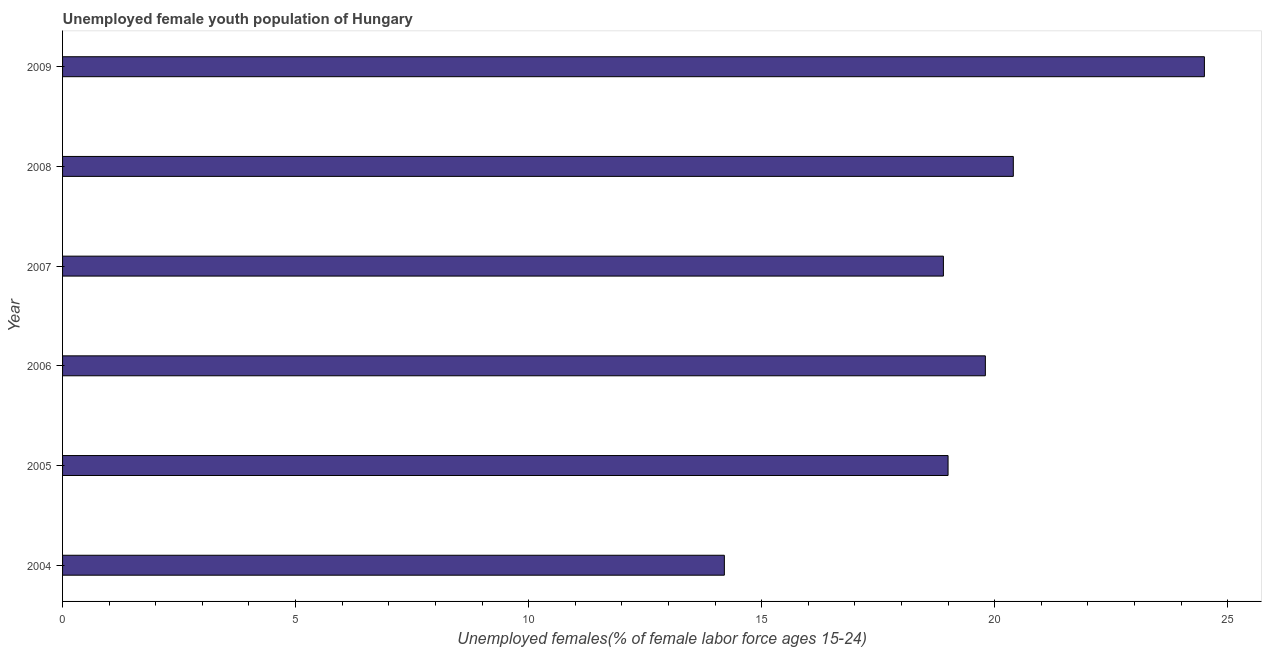Does the graph contain any zero values?
Provide a short and direct response. No. Does the graph contain grids?
Provide a short and direct response. No. What is the title of the graph?
Keep it short and to the point. Unemployed female youth population of Hungary. What is the label or title of the X-axis?
Keep it short and to the point. Unemployed females(% of female labor force ages 15-24). What is the label or title of the Y-axis?
Provide a succinct answer. Year. What is the unemployed female youth in 2004?
Provide a short and direct response. 14.2. Across all years, what is the minimum unemployed female youth?
Make the answer very short. 14.2. In which year was the unemployed female youth minimum?
Provide a short and direct response. 2004. What is the sum of the unemployed female youth?
Offer a very short reply. 116.8. What is the difference between the unemployed female youth in 2004 and 2007?
Your answer should be compact. -4.7. What is the average unemployed female youth per year?
Your answer should be compact. 19.47. What is the median unemployed female youth?
Your answer should be very brief. 19.4. In how many years, is the unemployed female youth greater than 20 %?
Provide a succinct answer. 2. What is the ratio of the unemployed female youth in 2006 to that in 2008?
Your response must be concise. 0.97. Is the unemployed female youth in 2005 less than that in 2006?
Offer a terse response. Yes. Is the sum of the unemployed female youth in 2004 and 2008 greater than the maximum unemployed female youth across all years?
Make the answer very short. Yes. In how many years, is the unemployed female youth greater than the average unemployed female youth taken over all years?
Offer a very short reply. 3. How many years are there in the graph?
Provide a succinct answer. 6. What is the difference between two consecutive major ticks on the X-axis?
Keep it short and to the point. 5. Are the values on the major ticks of X-axis written in scientific E-notation?
Make the answer very short. No. What is the Unemployed females(% of female labor force ages 15-24) in 2004?
Offer a very short reply. 14.2. What is the Unemployed females(% of female labor force ages 15-24) in 2006?
Keep it short and to the point. 19.8. What is the Unemployed females(% of female labor force ages 15-24) in 2007?
Ensure brevity in your answer.  18.9. What is the Unemployed females(% of female labor force ages 15-24) in 2008?
Ensure brevity in your answer.  20.4. What is the Unemployed females(% of female labor force ages 15-24) in 2009?
Provide a succinct answer. 24.5. What is the difference between the Unemployed females(% of female labor force ages 15-24) in 2004 and 2007?
Make the answer very short. -4.7. What is the difference between the Unemployed females(% of female labor force ages 15-24) in 2004 and 2008?
Your response must be concise. -6.2. What is the difference between the Unemployed females(% of female labor force ages 15-24) in 2005 and 2009?
Your answer should be very brief. -5.5. What is the difference between the Unemployed females(% of female labor force ages 15-24) in 2007 and 2009?
Provide a succinct answer. -5.6. What is the ratio of the Unemployed females(% of female labor force ages 15-24) in 2004 to that in 2005?
Give a very brief answer. 0.75. What is the ratio of the Unemployed females(% of female labor force ages 15-24) in 2004 to that in 2006?
Your response must be concise. 0.72. What is the ratio of the Unemployed females(% of female labor force ages 15-24) in 2004 to that in 2007?
Your response must be concise. 0.75. What is the ratio of the Unemployed females(% of female labor force ages 15-24) in 2004 to that in 2008?
Your answer should be very brief. 0.7. What is the ratio of the Unemployed females(% of female labor force ages 15-24) in 2004 to that in 2009?
Provide a succinct answer. 0.58. What is the ratio of the Unemployed females(% of female labor force ages 15-24) in 2005 to that in 2006?
Ensure brevity in your answer.  0.96. What is the ratio of the Unemployed females(% of female labor force ages 15-24) in 2005 to that in 2008?
Offer a terse response. 0.93. What is the ratio of the Unemployed females(% of female labor force ages 15-24) in 2005 to that in 2009?
Make the answer very short. 0.78. What is the ratio of the Unemployed females(% of female labor force ages 15-24) in 2006 to that in 2007?
Offer a terse response. 1.05. What is the ratio of the Unemployed females(% of female labor force ages 15-24) in 2006 to that in 2008?
Your answer should be compact. 0.97. What is the ratio of the Unemployed females(% of female labor force ages 15-24) in 2006 to that in 2009?
Provide a succinct answer. 0.81. What is the ratio of the Unemployed females(% of female labor force ages 15-24) in 2007 to that in 2008?
Your answer should be compact. 0.93. What is the ratio of the Unemployed females(% of female labor force ages 15-24) in 2007 to that in 2009?
Your answer should be compact. 0.77. What is the ratio of the Unemployed females(% of female labor force ages 15-24) in 2008 to that in 2009?
Your response must be concise. 0.83. 